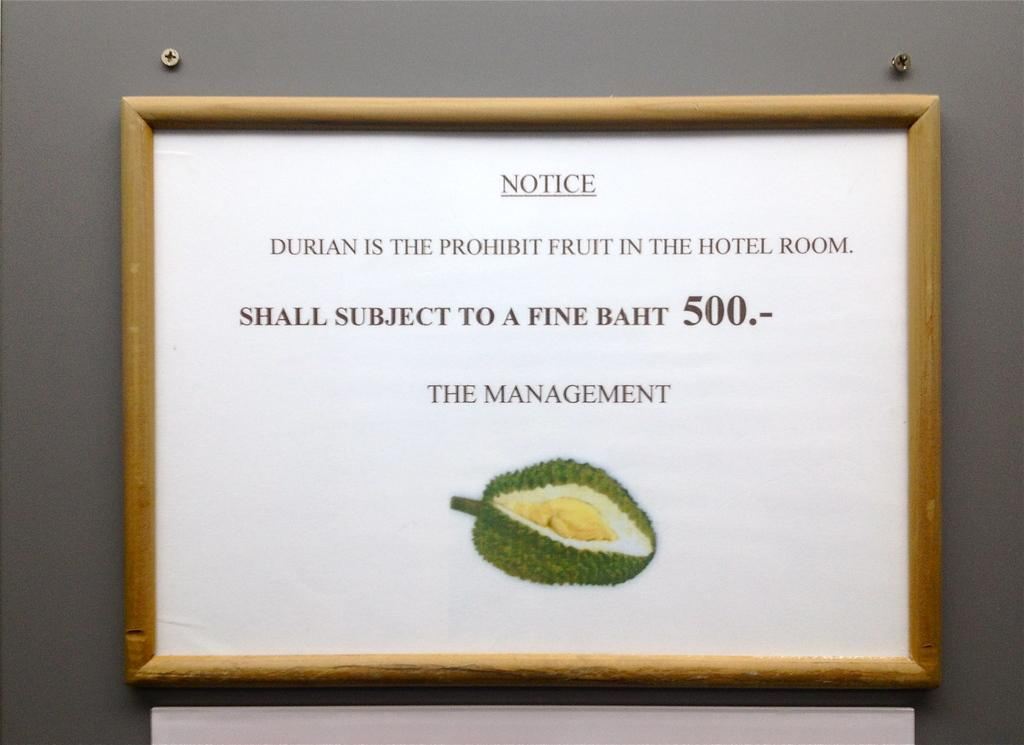Provide a one-sentence caption for the provided image. Framed picture with NOTICE DURIAN IS THE PROHIBIT FRUIT IN HOTEL ROOM with fine of 500 for failing to comply with management and an image of fruit. 